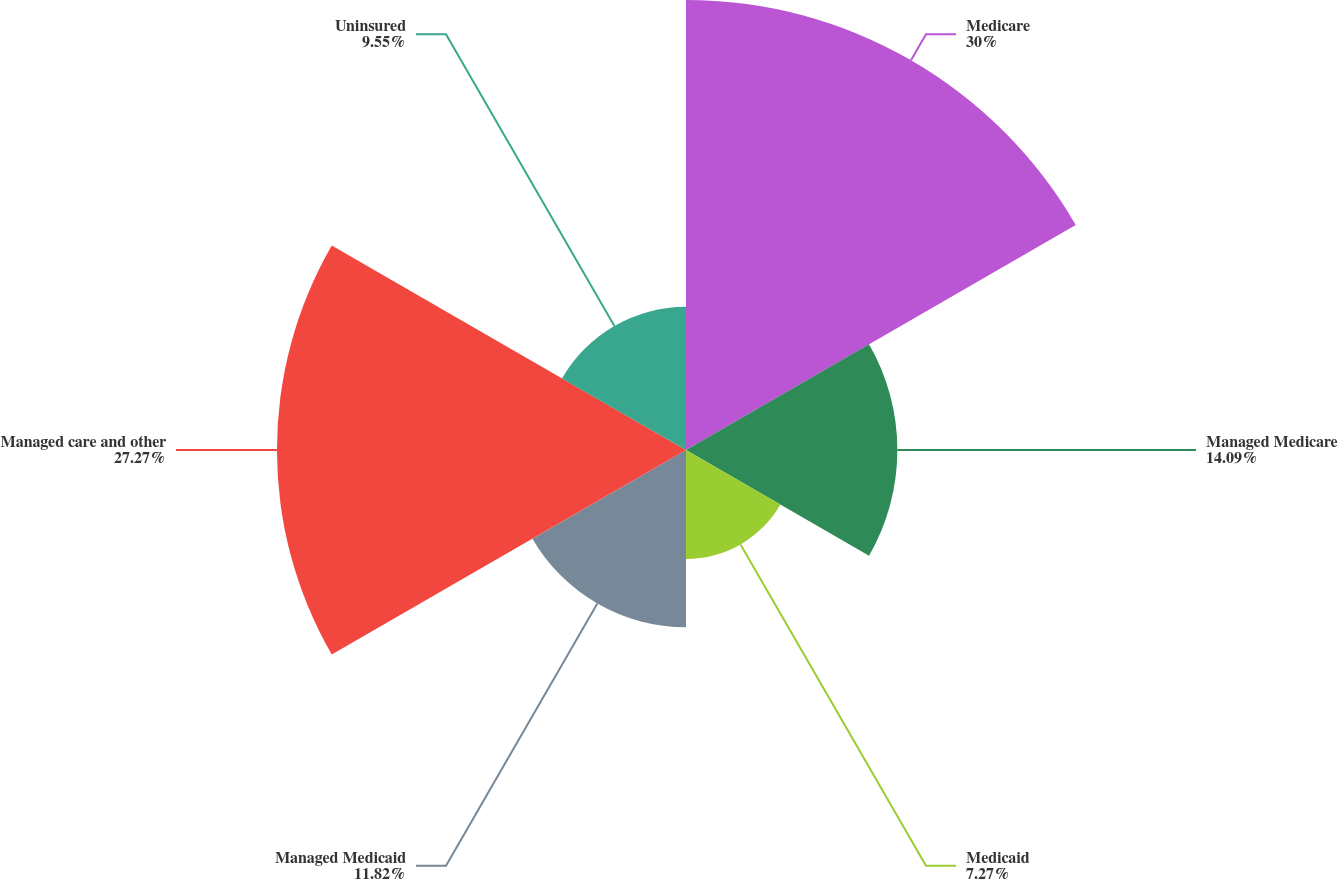Convert chart to OTSL. <chart><loc_0><loc_0><loc_500><loc_500><pie_chart><fcel>Medicare<fcel>Managed Medicare<fcel>Medicaid<fcel>Managed Medicaid<fcel>Managed care and other<fcel>Uninsured<nl><fcel>30.0%<fcel>14.09%<fcel>7.27%<fcel>11.82%<fcel>27.27%<fcel>9.55%<nl></chart> 